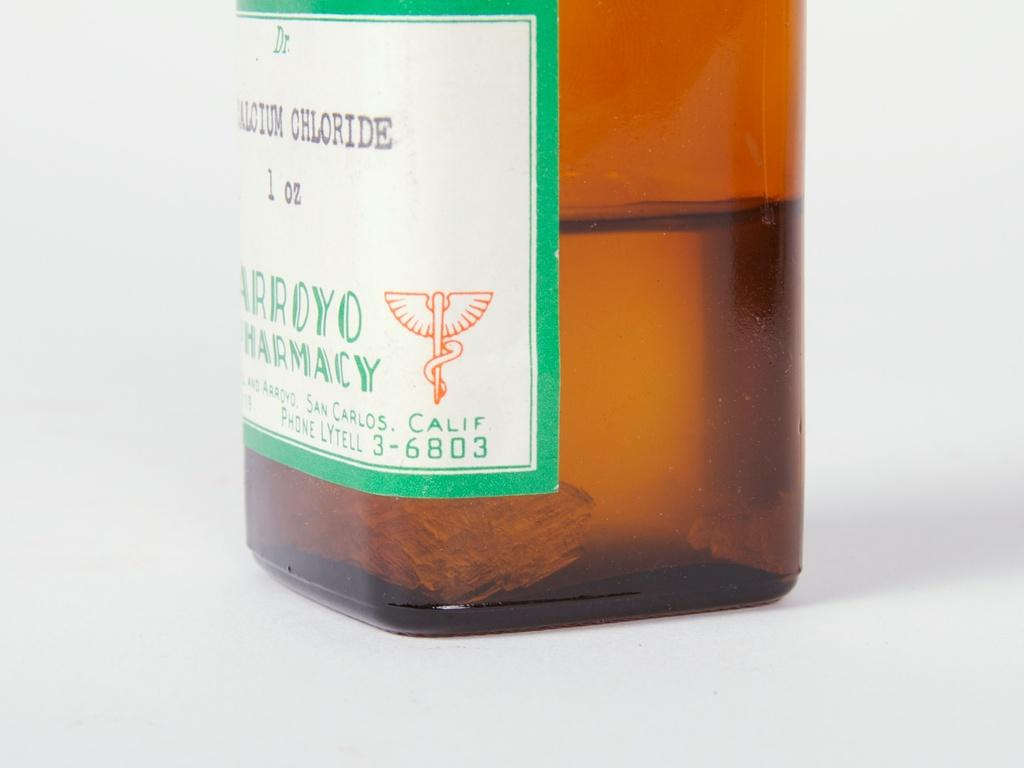<image>
Present a compact description of the photo's key features. a brown bottle of medication from arroyo pharmacy in california 